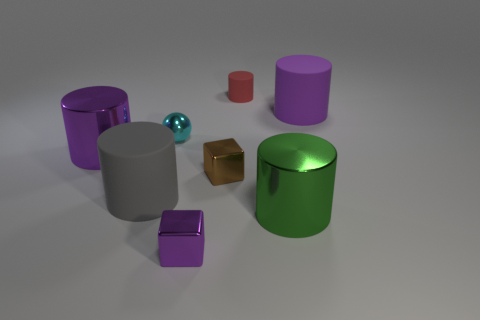Subtract all red cylinders. How many cylinders are left? 4 Subtract all green cylinders. How many cylinders are left? 4 Subtract all yellow cylinders. Subtract all yellow cubes. How many cylinders are left? 5 Add 2 large purple matte objects. How many objects exist? 10 Subtract all spheres. How many objects are left? 7 Add 5 small brown metal blocks. How many small brown metal blocks are left? 6 Add 8 large matte cylinders. How many large matte cylinders exist? 10 Subtract 0 blue cylinders. How many objects are left? 8 Subtract all large yellow metallic balls. Subtract all large purple shiny cylinders. How many objects are left? 7 